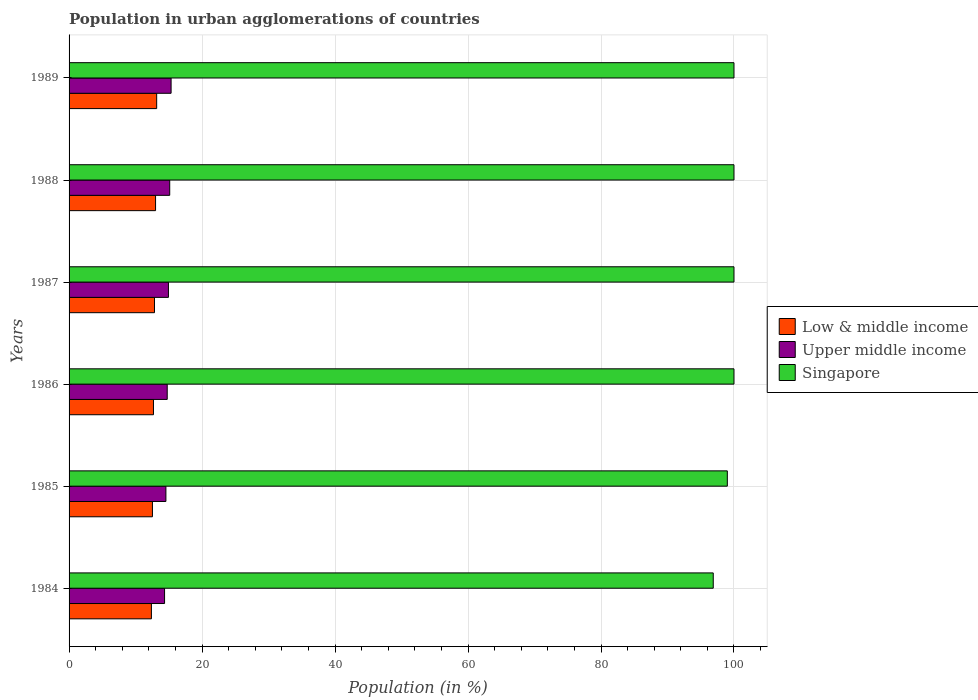Are the number of bars per tick equal to the number of legend labels?
Your response must be concise. Yes. How many bars are there on the 3rd tick from the top?
Make the answer very short. 3. How many bars are there on the 2nd tick from the bottom?
Provide a succinct answer. 3. In how many cases, is the number of bars for a given year not equal to the number of legend labels?
Give a very brief answer. 0. What is the percentage of population in urban agglomerations in Singapore in 1986?
Your answer should be compact. 100. Across all years, what is the maximum percentage of population in urban agglomerations in Low & middle income?
Offer a terse response. 13.18. Across all years, what is the minimum percentage of population in urban agglomerations in Singapore?
Keep it short and to the point. 96.88. What is the total percentage of population in urban agglomerations in Upper middle income in the graph?
Provide a short and direct response. 89.11. What is the difference between the percentage of population in urban agglomerations in Singapore in 1984 and that in 1985?
Give a very brief answer. -2.12. What is the difference between the percentage of population in urban agglomerations in Low & middle income in 1988 and the percentage of population in urban agglomerations in Upper middle income in 1986?
Your answer should be very brief. -1.75. What is the average percentage of population in urban agglomerations in Singapore per year?
Keep it short and to the point. 99.31. In the year 1984, what is the difference between the percentage of population in urban agglomerations in Low & middle income and percentage of population in urban agglomerations in Upper middle income?
Provide a short and direct response. -1.98. What is the ratio of the percentage of population in urban agglomerations in Upper middle income in 1987 to that in 1989?
Your response must be concise. 0.97. Is the difference between the percentage of population in urban agglomerations in Low & middle income in 1985 and 1986 greater than the difference between the percentage of population in urban agglomerations in Upper middle income in 1985 and 1986?
Your answer should be compact. Yes. What is the difference between the highest and the second highest percentage of population in urban agglomerations in Upper middle income?
Provide a succinct answer. 0.21. What is the difference between the highest and the lowest percentage of population in urban agglomerations in Singapore?
Your answer should be very brief. 3.12. In how many years, is the percentage of population in urban agglomerations in Low & middle income greater than the average percentage of population in urban agglomerations in Low & middle income taken over all years?
Ensure brevity in your answer.  3. What does the 3rd bar from the bottom in 1984 represents?
Offer a terse response. Singapore. Is it the case that in every year, the sum of the percentage of population in urban agglomerations in Upper middle income and percentage of population in urban agglomerations in Low & middle income is greater than the percentage of population in urban agglomerations in Singapore?
Your response must be concise. No. Are the values on the major ticks of X-axis written in scientific E-notation?
Provide a short and direct response. No. Where does the legend appear in the graph?
Provide a succinct answer. Center right. How many legend labels are there?
Ensure brevity in your answer.  3. How are the legend labels stacked?
Your answer should be compact. Vertical. What is the title of the graph?
Keep it short and to the point. Population in urban agglomerations of countries. What is the label or title of the X-axis?
Provide a succinct answer. Population (in %). What is the Population (in %) in Low & middle income in 1984?
Offer a terse response. 12.38. What is the Population (in %) in Upper middle income in 1984?
Offer a very short reply. 14.36. What is the Population (in %) of Singapore in 1984?
Give a very brief answer. 96.88. What is the Population (in %) in Low & middle income in 1985?
Ensure brevity in your answer.  12.54. What is the Population (in %) of Upper middle income in 1985?
Provide a succinct answer. 14.56. What is the Population (in %) of Singapore in 1985?
Ensure brevity in your answer.  99. What is the Population (in %) of Low & middle income in 1986?
Your response must be concise. 12.69. What is the Population (in %) in Upper middle income in 1986?
Ensure brevity in your answer.  14.76. What is the Population (in %) in Singapore in 1986?
Provide a succinct answer. 100. What is the Population (in %) of Low & middle income in 1987?
Your response must be concise. 12.85. What is the Population (in %) of Upper middle income in 1987?
Make the answer very short. 14.95. What is the Population (in %) in Low & middle income in 1988?
Ensure brevity in your answer.  13.01. What is the Population (in %) in Upper middle income in 1988?
Provide a succinct answer. 15.14. What is the Population (in %) of Low & middle income in 1989?
Offer a terse response. 13.18. What is the Population (in %) in Upper middle income in 1989?
Ensure brevity in your answer.  15.34. Across all years, what is the maximum Population (in %) of Low & middle income?
Offer a very short reply. 13.18. Across all years, what is the maximum Population (in %) of Upper middle income?
Give a very brief answer. 15.34. Across all years, what is the maximum Population (in %) of Singapore?
Make the answer very short. 100. Across all years, what is the minimum Population (in %) of Low & middle income?
Your answer should be very brief. 12.38. Across all years, what is the minimum Population (in %) in Upper middle income?
Your answer should be compact. 14.36. Across all years, what is the minimum Population (in %) in Singapore?
Provide a succinct answer. 96.88. What is the total Population (in %) of Low & middle income in the graph?
Provide a short and direct response. 76.64. What is the total Population (in %) of Upper middle income in the graph?
Your response must be concise. 89.11. What is the total Population (in %) in Singapore in the graph?
Provide a short and direct response. 595.88. What is the difference between the Population (in %) of Low & middle income in 1984 and that in 1985?
Offer a very short reply. -0.15. What is the difference between the Population (in %) of Upper middle income in 1984 and that in 1985?
Provide a succinct answer. -0.2. What is the difference between the Population (in %) in Singapore in 1984 and that in 1985?
Give a very brief answer. -2.12. What is the difference between the Population (in %) in Low & middle income in 1984 and that in 1986?
Offer a very short reply. -0.31. What is the difference between the Population (in %) of Upper middle income in 1984 and that in 1986?
Provide a succinct answer. -0.4. What is the difference between the Population (in %) of Singapore in 1984 and that in 1986?
Offer a terse response. -3.12. What is the difference between the Population (in %) in Low & middle income in 1984 and that in 1987?
Make the answer very short. -0.46. What is the difference between the Population (in %) of Upper middle income in 1984 and that in 1987?
Your answer should be compact. -0.58. What is the difference between the Population (in %) of Singapore in 1984 and that in 1987?
Provide a succinct answer. -3.12. What is the difference between the Population (in %) of Low & middle income in 1984 and that in 1988?
Provide a succinct answer. -0.62. What is the difference between the Population (in %) in Upper middle income in 1984 and that in 1988?
Your response must be concise. -0.77. What is the difference between the Population (in %) of Singapore in 1984 and that in 1988?
Provide a short and direct response. -3.12. What is the difference between the Population (in %) of Low & middle income in 1984 and that in 1989?
Make the answer very short. -0.79. What is the difference between the Population (in %) of Upper middle income in 1984 and that in 1989?
Your answer should be compact. -0.98. What is the difference between the Population (in %) in Singapore in 1984 and that in 1989?
Offer a very short reply. -3.12. What is the difference between the Population (in %) in Low & middle income in 1985 and that in 1986?
Provide a short and direct response. -0.16. What is the difference between the Population (in %) in Upper middle income in 1985 and that in 1986?
Your answer should be very brief. -0.2. What is the difference between the Population (in %) of Singapore in 1985 and that in 1986?
Make the answer very short. -1. What is the difference between the Population (in %) in Low & middle income in 1985 and that in 1987?
Offer a terse response. -0.31. What is the difference between the Population (in %) of Upper middle income in 1985 and that in 1987?
Keep it short and to the point. -0.38. What is the difference between the Population (in %) of Singapore in 1985 and that in 1987?
Ensure brevity in your answer.  -1. What is the difference between the Population (in %) in Low & middle income in 1985 and that in 1988?
Make the answer very short. -0.47. What is the difference between the Population (in %) of Upper middle income in 1985 and that in 1988?
Offer a terse response. -0.57. What is the difference between the Population (in %) in Singapore in 1985 and that in 1988?
Make the answer very short. -1. What is the difference between the Population (in %) of Low & middle income in 1985 and that in 1989?
Provide a short and direct response. -0.64. What is the difference between the Population (in %) in Upper middle income in 1985 and that in 1989?
Make the answer very short. -0.78. What is the difference between the Population (in %) in Singapore in 1985 and that in 1989?
Your response must be concise. -1. What is the difference between the Population (in %) of Low & middle income in 1986 and that in 1987?
Provide a succinct answer. -0.15. What is the difference between the Population (in %) in Upper middle income in 1986 and that in 1987?
Your answer should be very brief. -0.18. What is the difference between the Population (in %) of Singapore in 1986 and that in 1987?
Provide a succinct answer. 0. What is the difference between the Population (in %) in Low & middle income in 1986 and that in 1988?
Keep it short and to the point. -0.31. What is the difference between the Population (in %) of Upper middle income in 1986 and that in 1988?
Give a very brief answer. -0.37. What is the difference between the Population (in %) in Low & middle income in 1986 and that in 1989?
Give a very brief answer. -0.48. What is the difference between the Population (in %) in Upper middle income in 1986 and that in 1989?
Offer a terse response. -0.58. What is the difference between the Population (in %) of Singapore in 1986 and that in 1989?
Your answer should be compact. 0. What is the difference between the Population (in %) of Low & middle income in 1987 and that in 1988?
Provide a succinct answer. -0.16. What is the difference between the Population (in %) of Upper middle income in 1987 and that in 1988?
Provide a short and direct response. -0.19. What is the difference between the Population (in %) in Singapore in 1987 and that in 1988?
Your response must be concise. 0. What is the difference between the Population (in %) of Low & middle income in 1987 and that in 1989?
Give a very brief answer. -0.33. What is the difference between the Population (in %) of Upper middle income in 1987 and that in 1989?
Your answer should be compact. -0.4. What is the difference between the Population (in %) in Singapore in 1987 and that in 1989?
Provide a short and direct response. 0. What is the difference between the Population (in %) of Low & middle income in 1988 and that in 1989?
Ensure brevity in your answer.  -0.17. What is the difference between the Population (in %) of Upper middle income in 1988 and that in 1989?
Make the answer very short. -0.21. What is the difference between the Population (in %) of Low & middle income in 1984 and the Population (in %) of Upper middle income in 1985?
Offer a very short reply. -2.18. What is the difference between the Population (in %) in Low & middle income in 1984 and the Population (in %) in Singapore in 1985?
Provide a succinct answer. -86.62. What is the difference between the Population (in %) of Upper middle income in 1984 and the Population (in %) of Singapore in 1985?
Provide a succinct answer. -84.64. What is the difference between the Population (in %) in Low & middle income in 1984 and the Population (in %) in Upper middle income in 1986?
Ensure brevity in your answer.  -2.38. What is the difference between the Population (in %) of Low & middle income in 1984 and the Population (in %) of Singapore in 1986?
Offer a very short reply. -87.62. What is the difference between the Population (in %) in Upper middle income in 1984 and the Population (in %) in Singapore in 1986?
Your answer should be very brief. -85.64. What is the difference between the Population (in %) in Low & middle income in 1984 and the Population (in %) in Upper middle income in 1987?
Provide a short and direct response. -2.56. What is the difference between the Population (in %) in Low & middle income in 1984 and the Population (in %) in Singapore in 1987?
Provide a short and direct response. -87.62. What is the difference between the Population (in %) in Upper middle income in 1984 and the Population (in %) in Singapore in 1987?
Your response must be concise. -85.64. What is the difference between the Population (in %) of Low & middle income in 1984 and the Population (in %) of Upper middle income in 1988?
Keep it short and to the point. -2.75. What is the difference between the Population (in %) in Low & middle income in 1984 and the Population (in %) in Singapore in 1988?
Ensure brevity in your answer.  -87.62. What is the difference between the Population (in %) in Upper middle income in 1984 and the Population (in %) in Singapore in 1988?
Your answer should be compact. -85.64. What is the difference between the Population (in %) of Low & middle income in 1984 and the Population (in %) of Upper middle income in 1989?
Your answer should be compact. -2.96. What is the difference between the Population (in %) in Low & middle income in 1984 and the Population (in %) in Singapore in 1989?
Provide a short and direct response. -87.62. What is the difference between the Population (in %) of Upper middle income in 1984 and the Population (in %) of Singapore in 1989?
Offer a very short reply. -85.64. What is the difference between the Population (in %) in Low & middle income in 1985 and the Population (in %) in Upper middle income in 1986?
Ensure brevity in your answer.  -2.23. What is the difference between the Population (in %) of Low & middle income in 1985 and the Population (in %) of Singapore in 1986?
Provide a short and direct response. -87.46. What is the difference between the Population (in %) in Upper middle income in 1985 and the Population (in %) in Singapore in 1986?
Ensure brevity in your answer.  -85.44. What is the difference between the Population (in %) in Low & middle income in 1985 and the Population (in %) in Upper middle income in 1987?
Make the answer very short. -2.41. What is the difference between the Population (in %) in Low & middle income in 1985 and the Population (in %) in Singapore in 1987?
Offer a terse response. -87.46. What is the difference between the Population (in %) of Upper middle income in 1985 and the Population (in %) of Singapore in 1987?
Offer a very short reply. -85.44. What is the difference between the Population (in %) in Low & middle income in 1985 and the Population (in %) in Upper middle income in 1988?
Your answer should be compact. -2.6. What is the difference between the Population (in %) of Low & middle income in 1985 and the Population (in %) of Singapore in 1988?
Offer a terse response. -87.46. What is the difference between the Population (in %) of Upper middle income in 1985 and the Population (in %) of Singapore in 1988?
Provide a short and direct response. -85.44. What is the difference between the Population (in %) in Low & middle income in 1985 and the Population (in %) in Upper middle income in 1989?
Make the answer very short. -2.81. What is the difference between the Population (in %) of Low & middle income in 1985 and the Population (in %) of Singapore in 1989?
Provide a succinct answer. -87.46. What is the difference between the Population (in %) in Upper middle income in 1985 and the Population (in %) in Singapore in 1989?
Offer a very short reply. -85.44. What is the difference between the Population (in %) of Low & middle income in 1986 and the Population (in %) of Upper middle income in 1987?
Keep it short and to the point. -2.25. What is the difference between the Population (in %) of Low & middle income in 1986 and the Population (in %) of Singapore in 1987?
Offer a terse response. -87.31. What is the difference between the Population (in %) of Upper middle income in 1986 and the Population (in %) of Singapore in 1987?
Offer a terse response. -85.24. What is the difference between the Population (in %) in Low & middle income in 1986 and the Population (in %) in Upper middle income in 1988?
Your answer should be very brief. -2.44. What is the difference between the Population (in %) of Low & middle income in 1986 and the Population (in %) of Singapore in 1988?
Provide a short and direct response. -87.31. What is the difference between the Population (in %) of Upper middle income in 1986 and the Population (in %) of Singapore in 1988?
Provide a short and direct response. -85.24. What is the difference between the Population (in %) of Low & middle income in 1986 and the Population (in %) of Upper middle income in 1989?
Offer a terse response. -2.65. What is the difference between the Population (in %) of Low & middle income in 1986 and the Population (in %) of Singapore in 1989?
Give a very brief answer. -87.31. What is the difference between the Population (in %) of Upper middle income in 1986 and the Population (in %) of Singapore in 1989?
Provide a short and direct response. -85.24. What is the difference between the Population (in %) in Low & middle income in 1987 and the Population (in %) in Upper middle income in 1988?
Provide a succinct answer. -2.29. What is the difference between the Population (in %) in Low & middle income in 1987 and the Population (in %) in Singapore in 1988?
Make the answer very short. -87.15. What is the difference between the Population (in %) of Upper middle income in 1987 and the Population (in %) of Singapore in 1988?
Your answer should be compact. -85.05. What is the difference between the Population (in %) in Low & middle income in 1987 and the Population (in %) in Upper middle income in 1989?
Make the answer very short. -2.5. What is the difference between the Population (in %) in Low & middle income in 1987 and the Population (in %) in Singapore in 1989?
Provide a succinct answer. -87.15. What is the difference between the Population (in %) of Upper middle income in 1987 and the Population (in %) of Singapore in 1989?
Keep it short and to the point. -85.05. What is the difference between the Population (in %) in Low & middle income in 1988 and the Population (in %) in Upper middle income in 1989?
Offer a terse response. -2.34. What is the difference between the Population (in %) in Low & middle income in 1988 and the Population (in %) in Singapore in 1989?
Ensure brevity in your answer.  -86.99. What is the difference between the Population (in %) in Upper middle income in 1988 and the Population (in %) in Singapore in 1989?
Keep it short and to the point. -84.86. What is the average Population (in %) of Low & middle income per year?
Provide a short and direct response. 12.77. What is the average Population (in %) in Upper middle income per year?
Your response must be concise. 14.85. What is the average Population (in %) in Singapore per year?
Ensure brevity in your answer.  99.31. In the year 1984, what is the difference between the Population (in %) in Low & middle income and Population (in %) in Upper middle income?
Make the answer very short. -1.98. In the year 1984, what is the difference between the Population (in %) in Low & middle income and Population (in %) in Singapore?
Your answer should be very brief. -84.5. In the year 1984, what is the difference between the Population (in %) in Upper middle income and Population (in %) in Singapore?
Ensure brevity in your answer.  -82.52. In the year 1985, what is the difference between the Population (in %) of Low & middle income and Population (in %) of Upper middle income?
Offer a terse response. -2.03. In the year 1985, what is the difference between the Population (in %) of Low & middle income and Population (in %) of Singapore?
Offer a very short reply. -86.46. In the year 1985, what is the difference between the Population (in %) of Upper middle income and Population (in %) of Singapore?
Offer a very short reply. -84.44. In the year 1986, what is the difference between the Population (in %) of Low & middle income and Population (in %) of Upper middle income?
Make the answer very short. -2.07. In the year 1986, what is the difference between the Population (in %) of Low & middle income and Population (in %) of Singapore?
Provide a short and direct response. -87.31. In the year 1986, what is the difference between the Population (in %) in Upper middle income and Population (in %) in Singapore?
Your answer should be compact. -85.24. In the year 1987, what is the difference between the Population (in %) in Low & middle income and Population (in %) in Upper middle income?
Your answer should be very brief. -2.1. In the year 1987, what is the difference between the Population (in %) of Low & middle income and Population (in %) of Singapore?
Give a very brief answer. -87.15. In the year 1987, what is the difference between the Population (in %) of Upper middle income and Population (in %) of Singapore?
Offer a terse response. -85.05. In the year 1988, what is the difference between the Population (in %) in Low & middle income and Population (in %) in Upper middle income?
Give a very brief answer. -2.13. In the year 1988, what is the difference between the Population (in %) of Low & middle income and Population (in %) of Singapore?
Your answer should be very brief. -86.99. In the year 1988, what is the difference between the Population (in %) in Upper middle income and Population (in %) in Singapore?
Your answer should be compact. -84.86. In the year 1989, what is the difference between the Population (in %) of Low & middle income and Population (in %) of Upper middle income?
Make the answer very short. -2.17. In the year 1989, what is the difference between the Population (in %) of Low & middle income and Population (in %) of Singapore?
Keep it short and to the point. -86.82. In the year 1989, what is the difference between the Population (in %) in Upper middle income and Population (in %) in Singapore?
Your answer should be compact. -84.66. What is the ratio of the Population (in %) of Low & middle income in 1984 to that in 1985?
Ensure brevity in your answer.  0.99. What is the ratio of the Population (in %) in Upper middle income in 1984 to that in 1985?
Your response must be concise. 0.99. What is the ratio of the Population (in %) in Singapore in 1984 to that in 1985?
Make the answer very short. 0.98. What is the ratio of the Population (in %) of Low & middle income in 1984 to that in 1986?
Provide a succinct answer. 0.98. What is the ratio of the Population (in %) in Upper middle income in 1984 to that in 1986?
Keep it short and to the point. 0.97. What is the ratio of the Population (in %) of Singapore in 1984 to that in 1986?
Provide a succinct answer. 0.97. What is the ratio of the Population (in %) in Low & middle income in 1984 to that in 1987?
Offer a terse response. 0.96. What is the ratio of the Population (in %) of Upper middle income in 1984 to that in 1987?
Keep it short and to the point. 0.96. What is the ratio of the Population (in %) in Singapore in 1984 to that in 1987?
Make the answer very short. 0.97. What is the ratio of the Population (in %) of Low & middle income in 1984 to that in 1988?
Offer a terse response. 0.95. What is the ratio of the Population (in %) in Upper middle income in 1984 to that in 1988?
Offer a terse response. 0.95. What is the ratio of the Population (in %) in Singapore in 1984 to that in 1988?
Your answer should be very brief. 0.97. What is the ratio of the Population (in %) of Low & middle income in 1984 to that in 1989?
Your response must be concise. 0.94. What is the ratio of the Population (in %) of Upper middle income in 1984 to that in 1989?
Provide a short and direct response. 0.94. What is the ratio of the Population (in %) in Singapore in 1984 to that in 1989?
Your response must be concise. 0.97. What is the ratio of the Population (in %) of Low & middle income in 1985 to that in 1986?
Give a very brief answer. 0.99. What is the ratio of the Population (in %) of Upper middle income in 1985 to that in 1986?
Make the answer very short. 0.99. What is the ratio of the Population (in %) in Singapore in 1985 to that in 1986?
Your response must be concise. 0.99. What is the ratio of the Population (in %) of Low & middle income in 1985 to that in 1987?
Give a very brief answer. 0.98. What is the ratio of the Population (in %) in Upper middle income in 1985 to that in 1987?
Give a very brief answer. 0.97. What is the ratio of the Population (in %) of Singapore in 1985 to that in 1987?
Your answer should be compact. 0.99. What is the ratio of the Population (in %) of Low & middle income in 1985 to that in 1988?
Provide a succinct answer. 0.96. What is the ratio of the Population (in %) in Upper middle income in 1985 to that in 1988?
Make the answer very short. 0.96. What is the ratio of the Population (in %) of Singapore in 1985 to that in 1988?
Provide a short and direct response. 0.99. What is the ratio of the Population (in %) in Low & middle income in 1985 to that in 1989?
Your answer should be very brief. 0.95. What is the ratio of the Population (in %) of Upper middle income in 1985 to that in 1989?
Offer a terse response. 0.95. What is the ratio of the Population (in %) in Upper middle income in 1986 to that in 1987?
Keep it short and to the point. 0.99. What is the ratio of the Population (in %) of Singapore in 1986 to that in 1987?
Offer a terse response. 1. What is the ratio of the Population (in %) of Low & middle income in 1986 to that in 1988?
Offer a very short reply. 0.98. What is the ratio of the Population (in %) in Upper middle income in 1986 to that in 1988?
Keep it short and to the point. 0.98. What is the ratio of the Population (in %) of Singapore in 1986 to that in 1988?
Provide a short and direct response. 1. What is the ratio of the Population (in %) in Low & middle income in 1986 to that in 1989?
Your answer should be compact. 0.96. What is the ratio of the Population (in %) of Upper middle income in 1986 to that in 1989?
Keep it short and to the point. 0.96. What is the ratio of the Population (in %) of Upper middle income in 1987 to that in 1988?
Keep it short and to the point. 0.99. What is the ratio of the Population (in %) of Low & middle income in 1987 to that in 1989?
Make the answer very short. 0.97. What is the ratio of the Population (in %) in Upper middle income in 1987 to that in 1989?
Offer a terse response. 0.97. What is the ratio of the Population (in %) in Low & middle income in 1988 to that in 1989?
Provide a succinct answer. 0.99. What is the ratio of the Population (in %) of Upper middle income in 1988 to that in 1989?
Make the answer very short. 0.99. What is the ratio of the Population (in %) in Singapore in 1988 to that in 1989?
Your answer should be very brief. 1. What is the difference between the highest and the second highest Population (in %) in Low & middle income?
Offer a very short reply. 0.17. What is the difference between the highest and the second highest Population (in %) in Upper middle income?
Make the answer very short. 0.21. What is the difference between the highest and the lowest Population (in %) in Low & middle income?
Give a very brief answer. 0.79. What is the difference between the highest and the lowest Population (in %) in Upper middle income?
Your answer should be very brief. 0.98. What is the difference between the highest and the lowest Population (in %) in Singapore?
Make the answer very short. 3.12. 